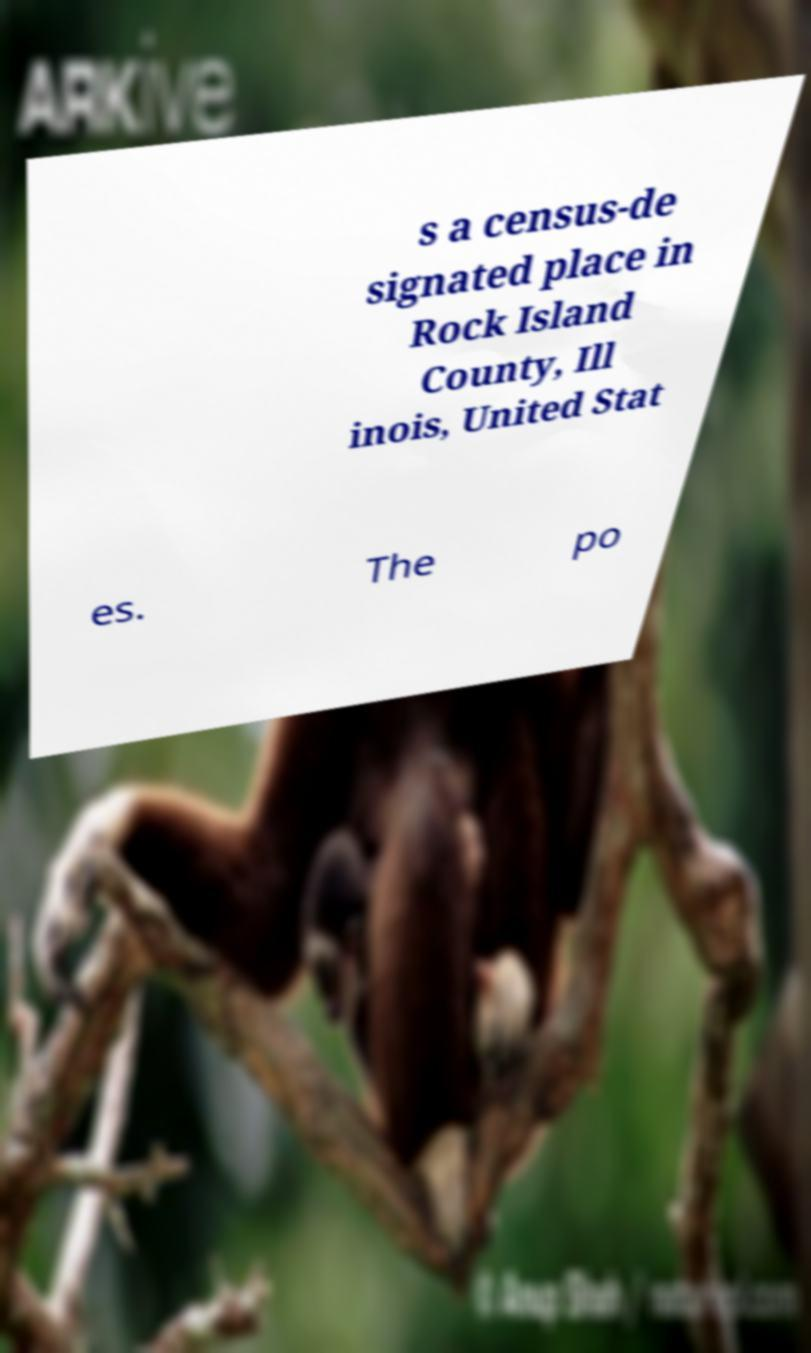Can you read and provide the text displayed in the image?This photo seems to have some interesting text. Can you extract and type it out for me? s a census-de signated place in Rock Island County, Ill inois, United Stat es. The po 